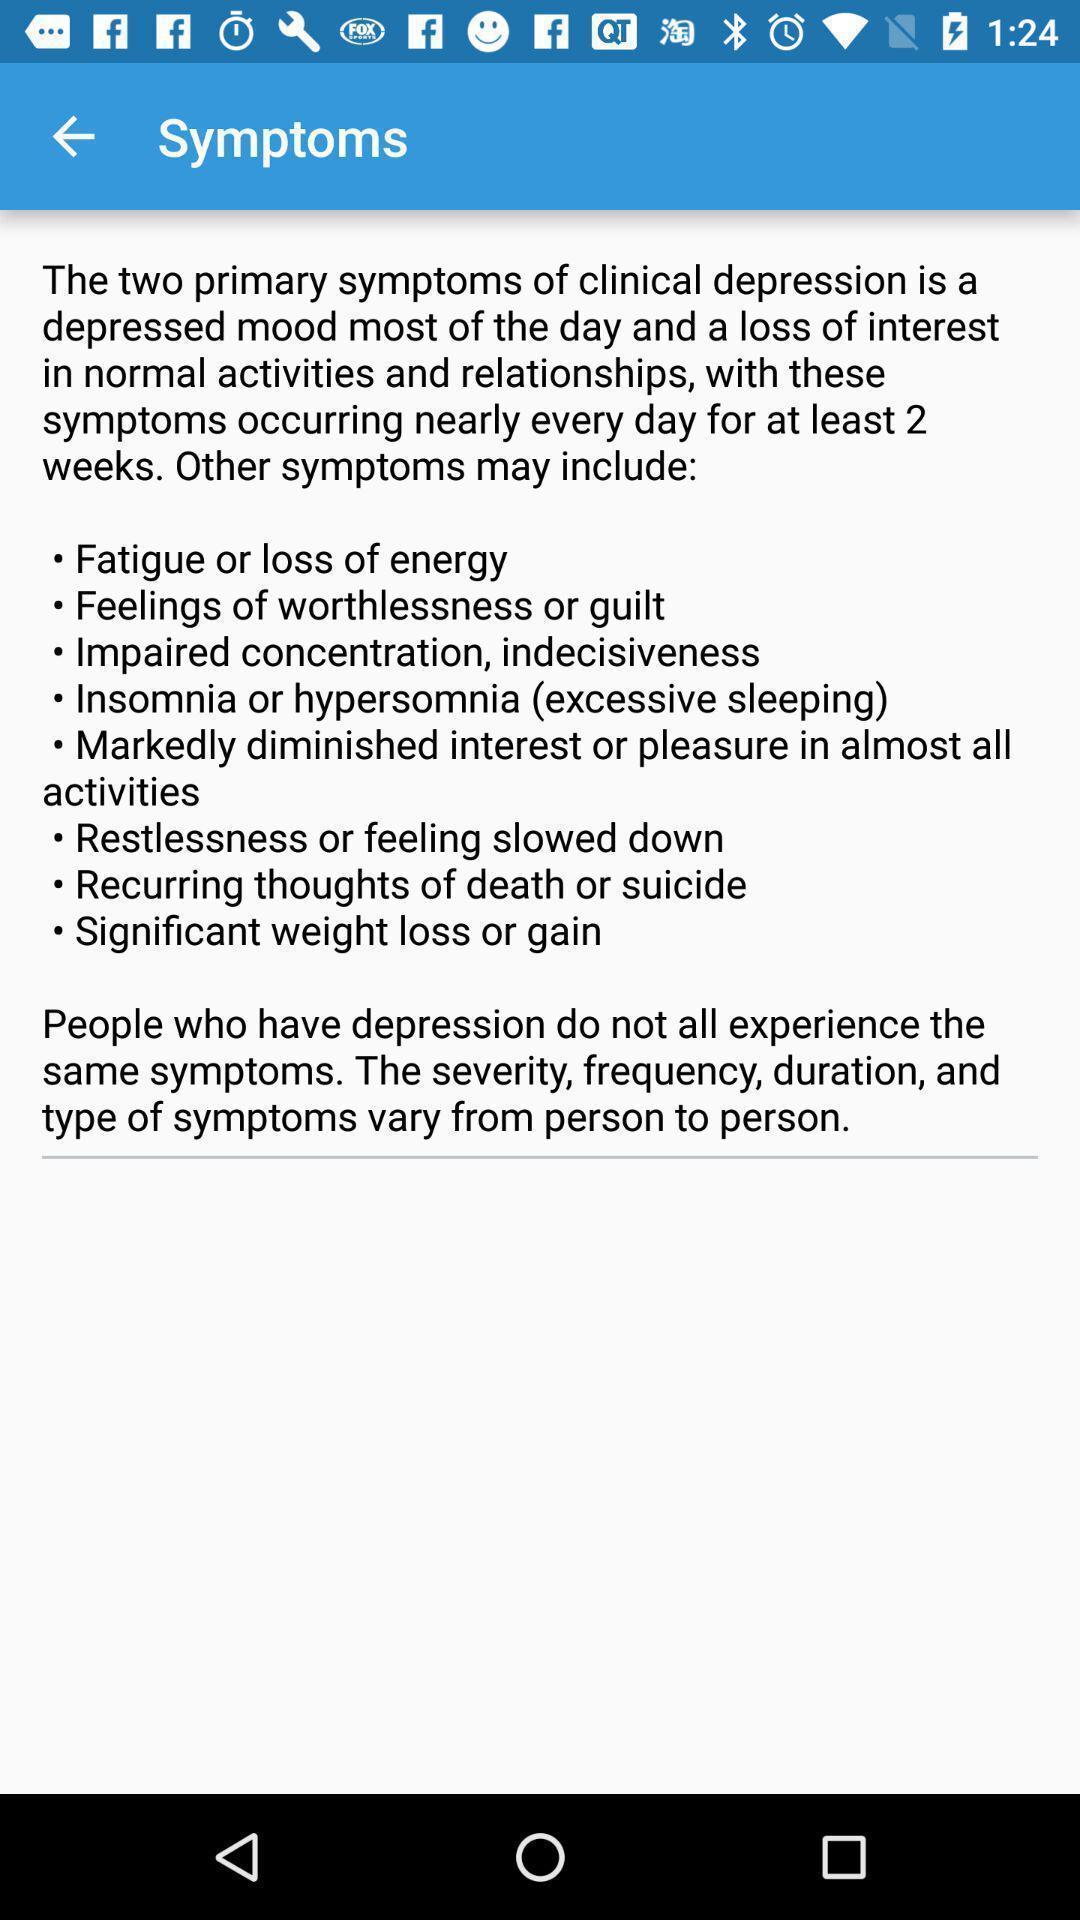What can you discern from this picture? Symptoms page. 